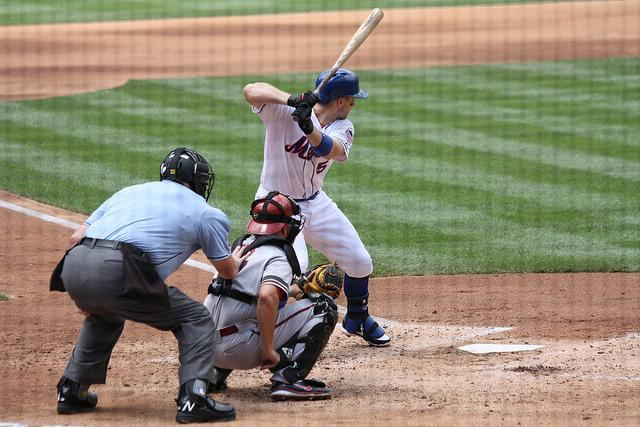What number is the batter? Please explain your reasoning. five. It is on the front of his shirt 